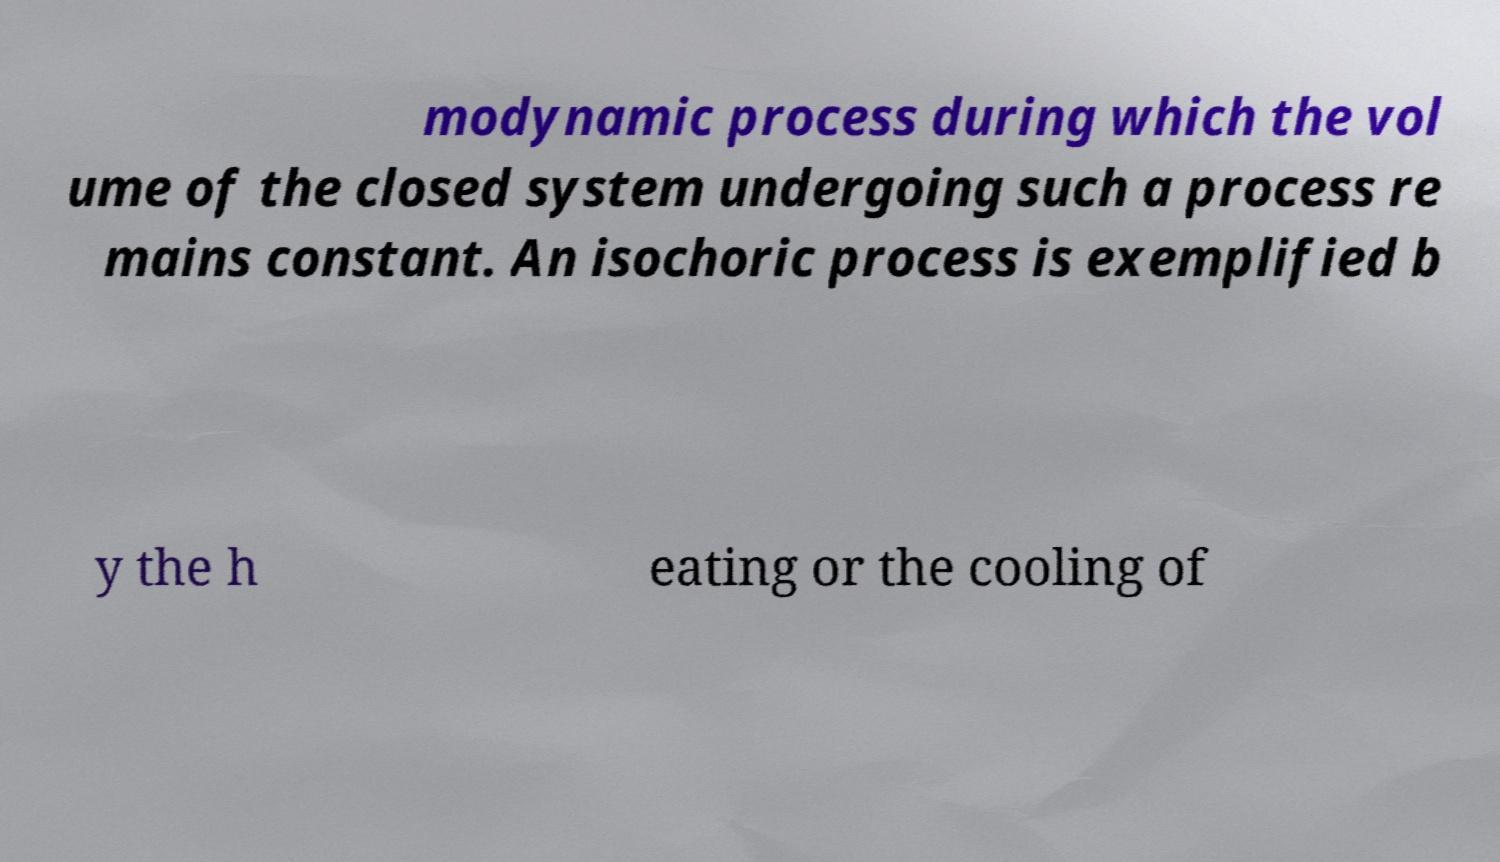Could you extract and type out the text from this image? modynamic process during which the vol ume of the closed system undergoing such a process re mains constant. An isochoric process is exemplified b y the h eating or the cooling of 